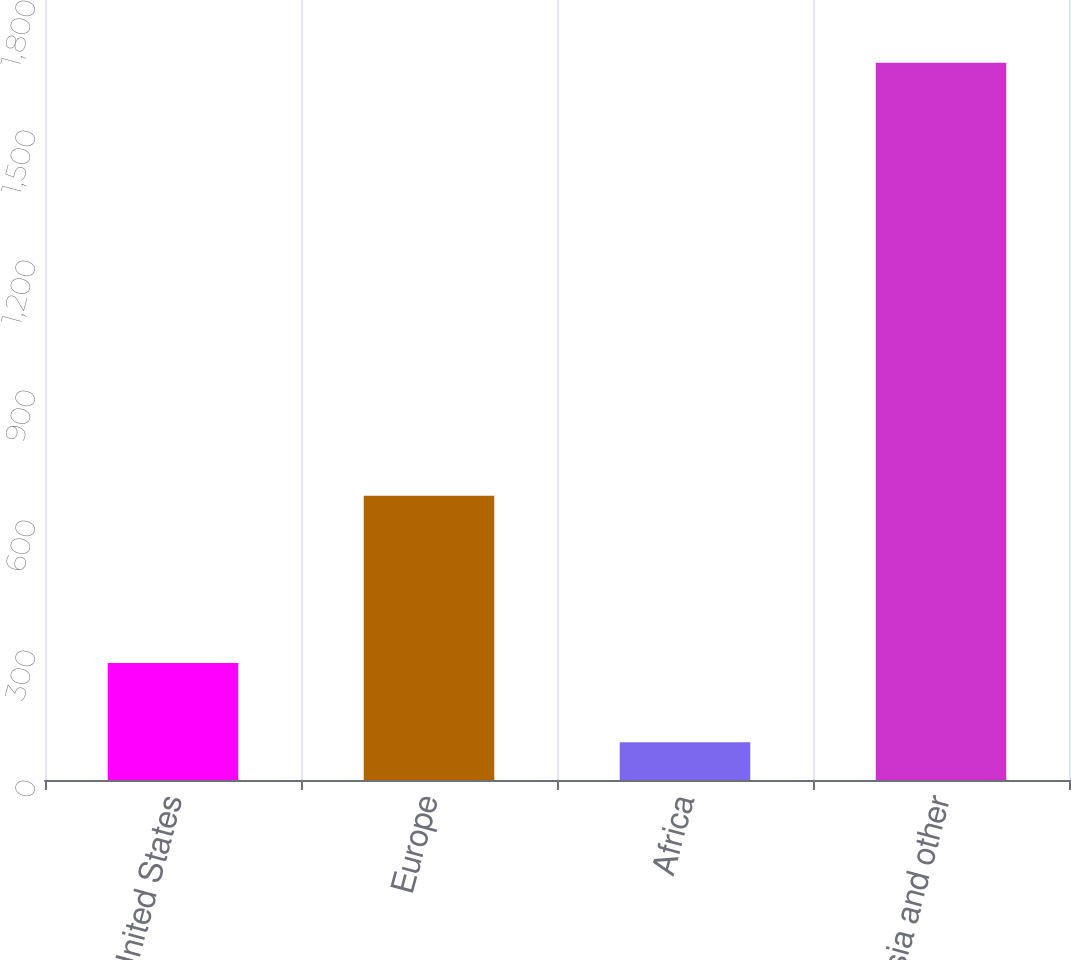Convert chart to OTSL. <chart><loc_0><loc_0><loc_500><loc_500><bar_chart><fcel>United States<fcel>Europe<fcel>Africa<fcel>Asia and other<nl><fcel>270<fcel>656<fcel>87<fcel>1655<nl></chart> 